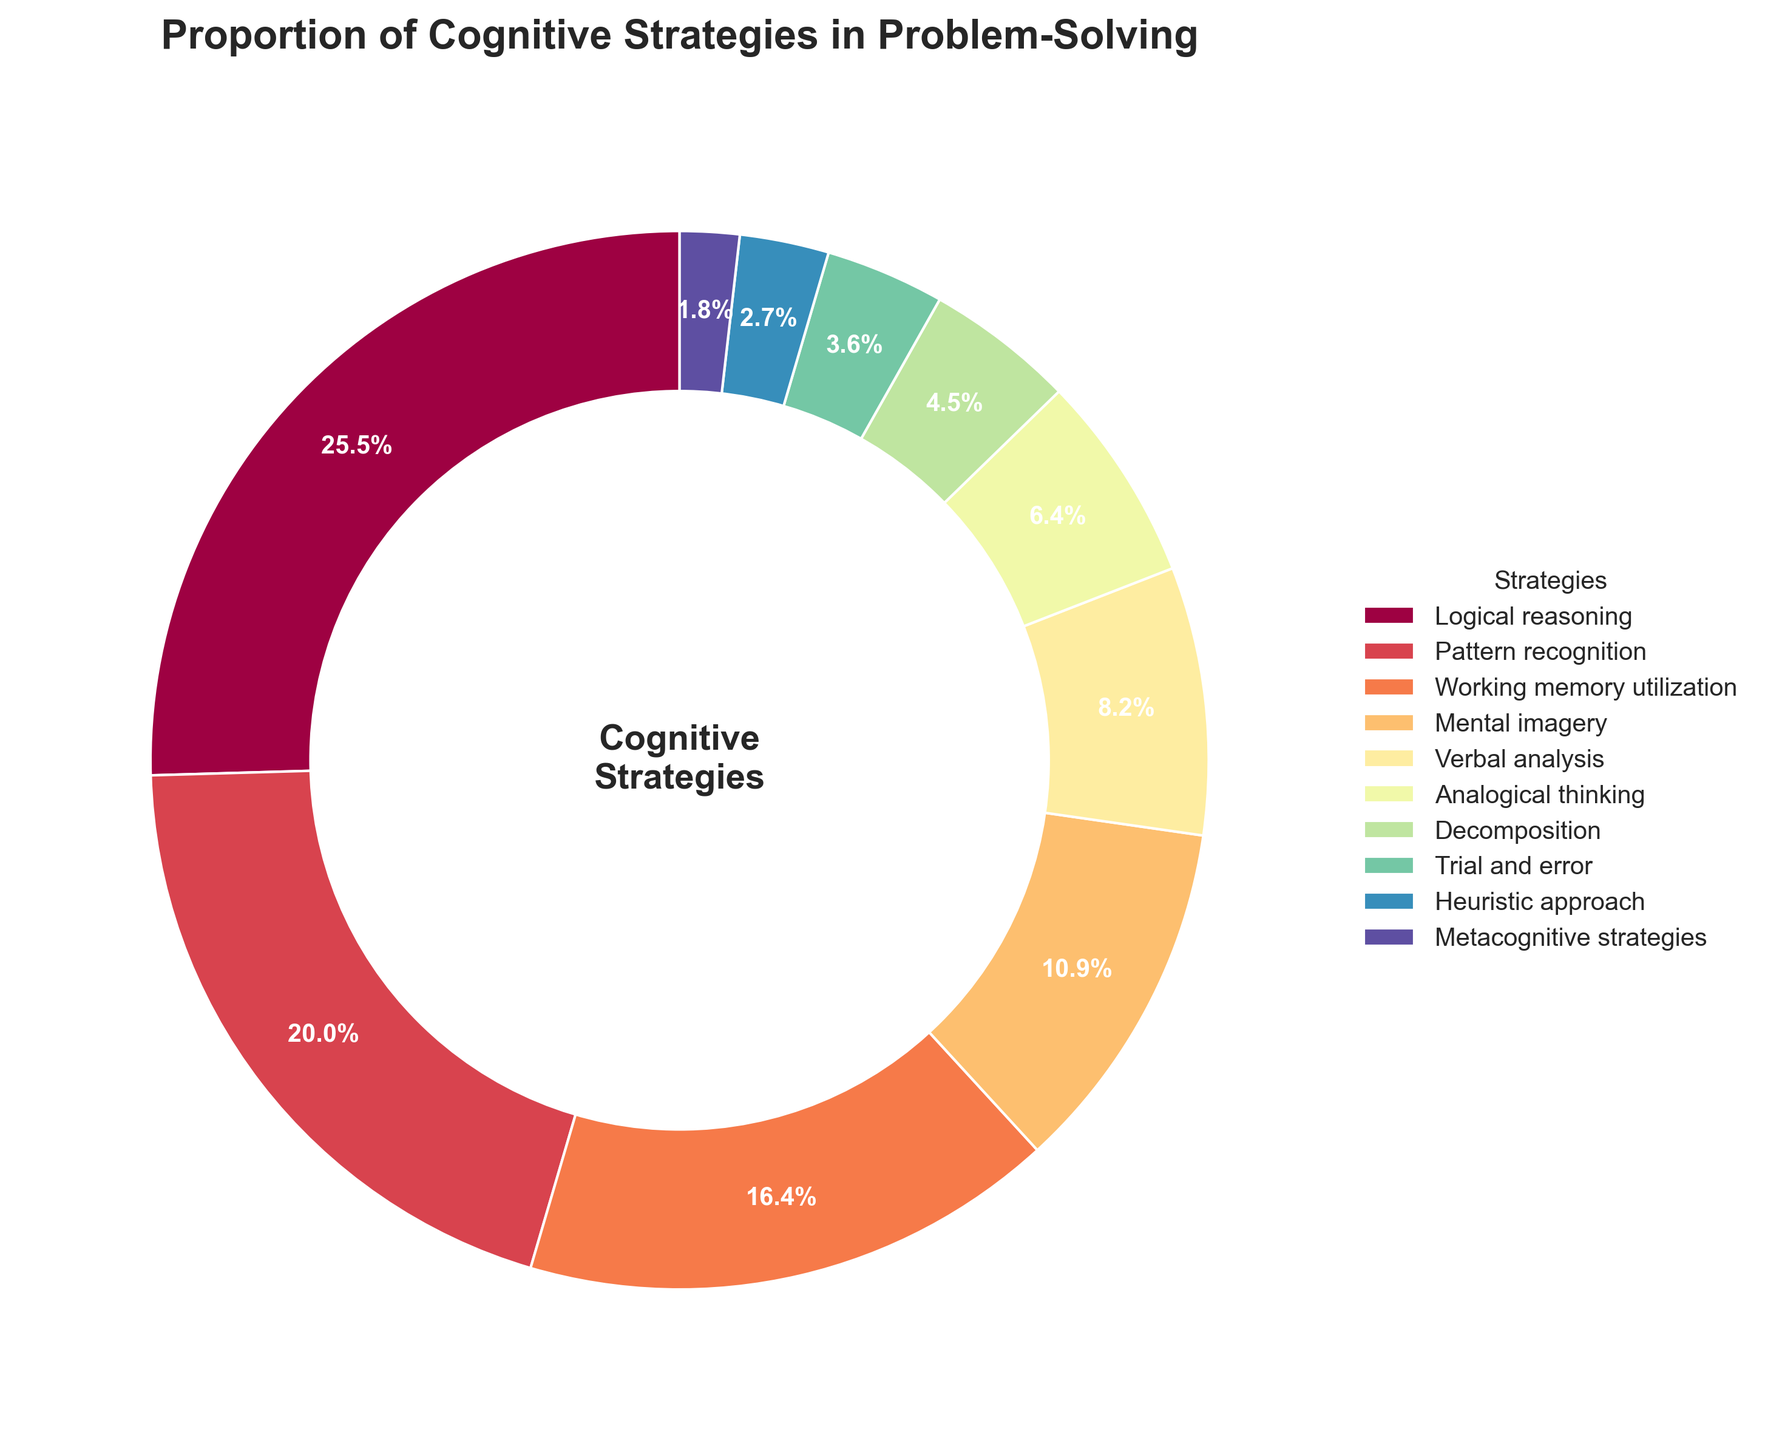What is the most frequently used cognitive strategy in problem-solving according to the pie chart? The largest segment in the pie chart represents Logical reasoning. This indicates it is the most frequently used strategy.
Answer: Logical reasoning Which cognitive strategy is used more, Pattern recognition or Working memory utilization? The segments for Pattern recognition and Working memory utilization in the chart show that Pattern recognition (22%) is larger than Working memory utilization (18%).
Answer: Pattern recognition What is the combined percentage of the less frequently used strategies (with percentages below 5%)? Adding the percentages of less frequently used strategies: Decomposition (5%), Trial and error (4%), Heuristic approach (3%), and Metacognitive strategies (2%) results in 5 + 4 + 3 + 2 = 14%.
Answer: 14% How much more is the percentage of Logical reasoning than the percentage of Verbal analysis? The percentage of Logical reasoning is 28%, and that of Verbal analysis is 9%. The difference is 28 - 9 = 19%.
Answer: 19% Are there more individuals who use Mental imagery or Analogical thinking? Mental imagery has a percentage of 12%, whereas Analogical thinking has 7%. Therefore, more individuals use Mental imagery.
Answer: Mental imagery Which four cognitive strategies together make up exactly half of the pie chart? Summing the top four strategies: Logical reasoning (28%), Pattern recognition (22%), Working memory utilization (18%), and Mental imagery (12%) results in 28 + 22 + 18 + 12 = 80%. Therefore, the top four strategies together do not make up exactly half, but instead 80%. The task is incorrect because no exact half can be formed by summing percentages of any four strategies. However, Logical reasoning and Pattern recognition together make up 28 + 22 = 50%.
Answer: Logical reasoning and Pattern recognition How does the usage of the Heuristic approach compare to that of Metacognitive strategies? The percentage for the Heuristic approach is 3%, and for Metacognitive strategies, it is 2%. Thus, the Heuristic approach is used slightly more often.
Answer: Heuristic approach Which cognitive strategies have a cumulative percentage equal to that of Logical reasoning? The strategy with the highest percentage is Logical reasoning at 28%. To find a cumulative percentage of smaller strategies equaling this, we combine individual strategies: Pattern recognition (22%) and Metacognitive strategies (2%) together with one more strategy. Have total less than Logical Reasoning's percentage. So, Pattern recognition (22%) and working memory utilization (18%) almost equal to logical reasoning (since they have an intersection of 28% overall logical reasoning percentage).
Answer: Pattern recognition and Working memory utilization 